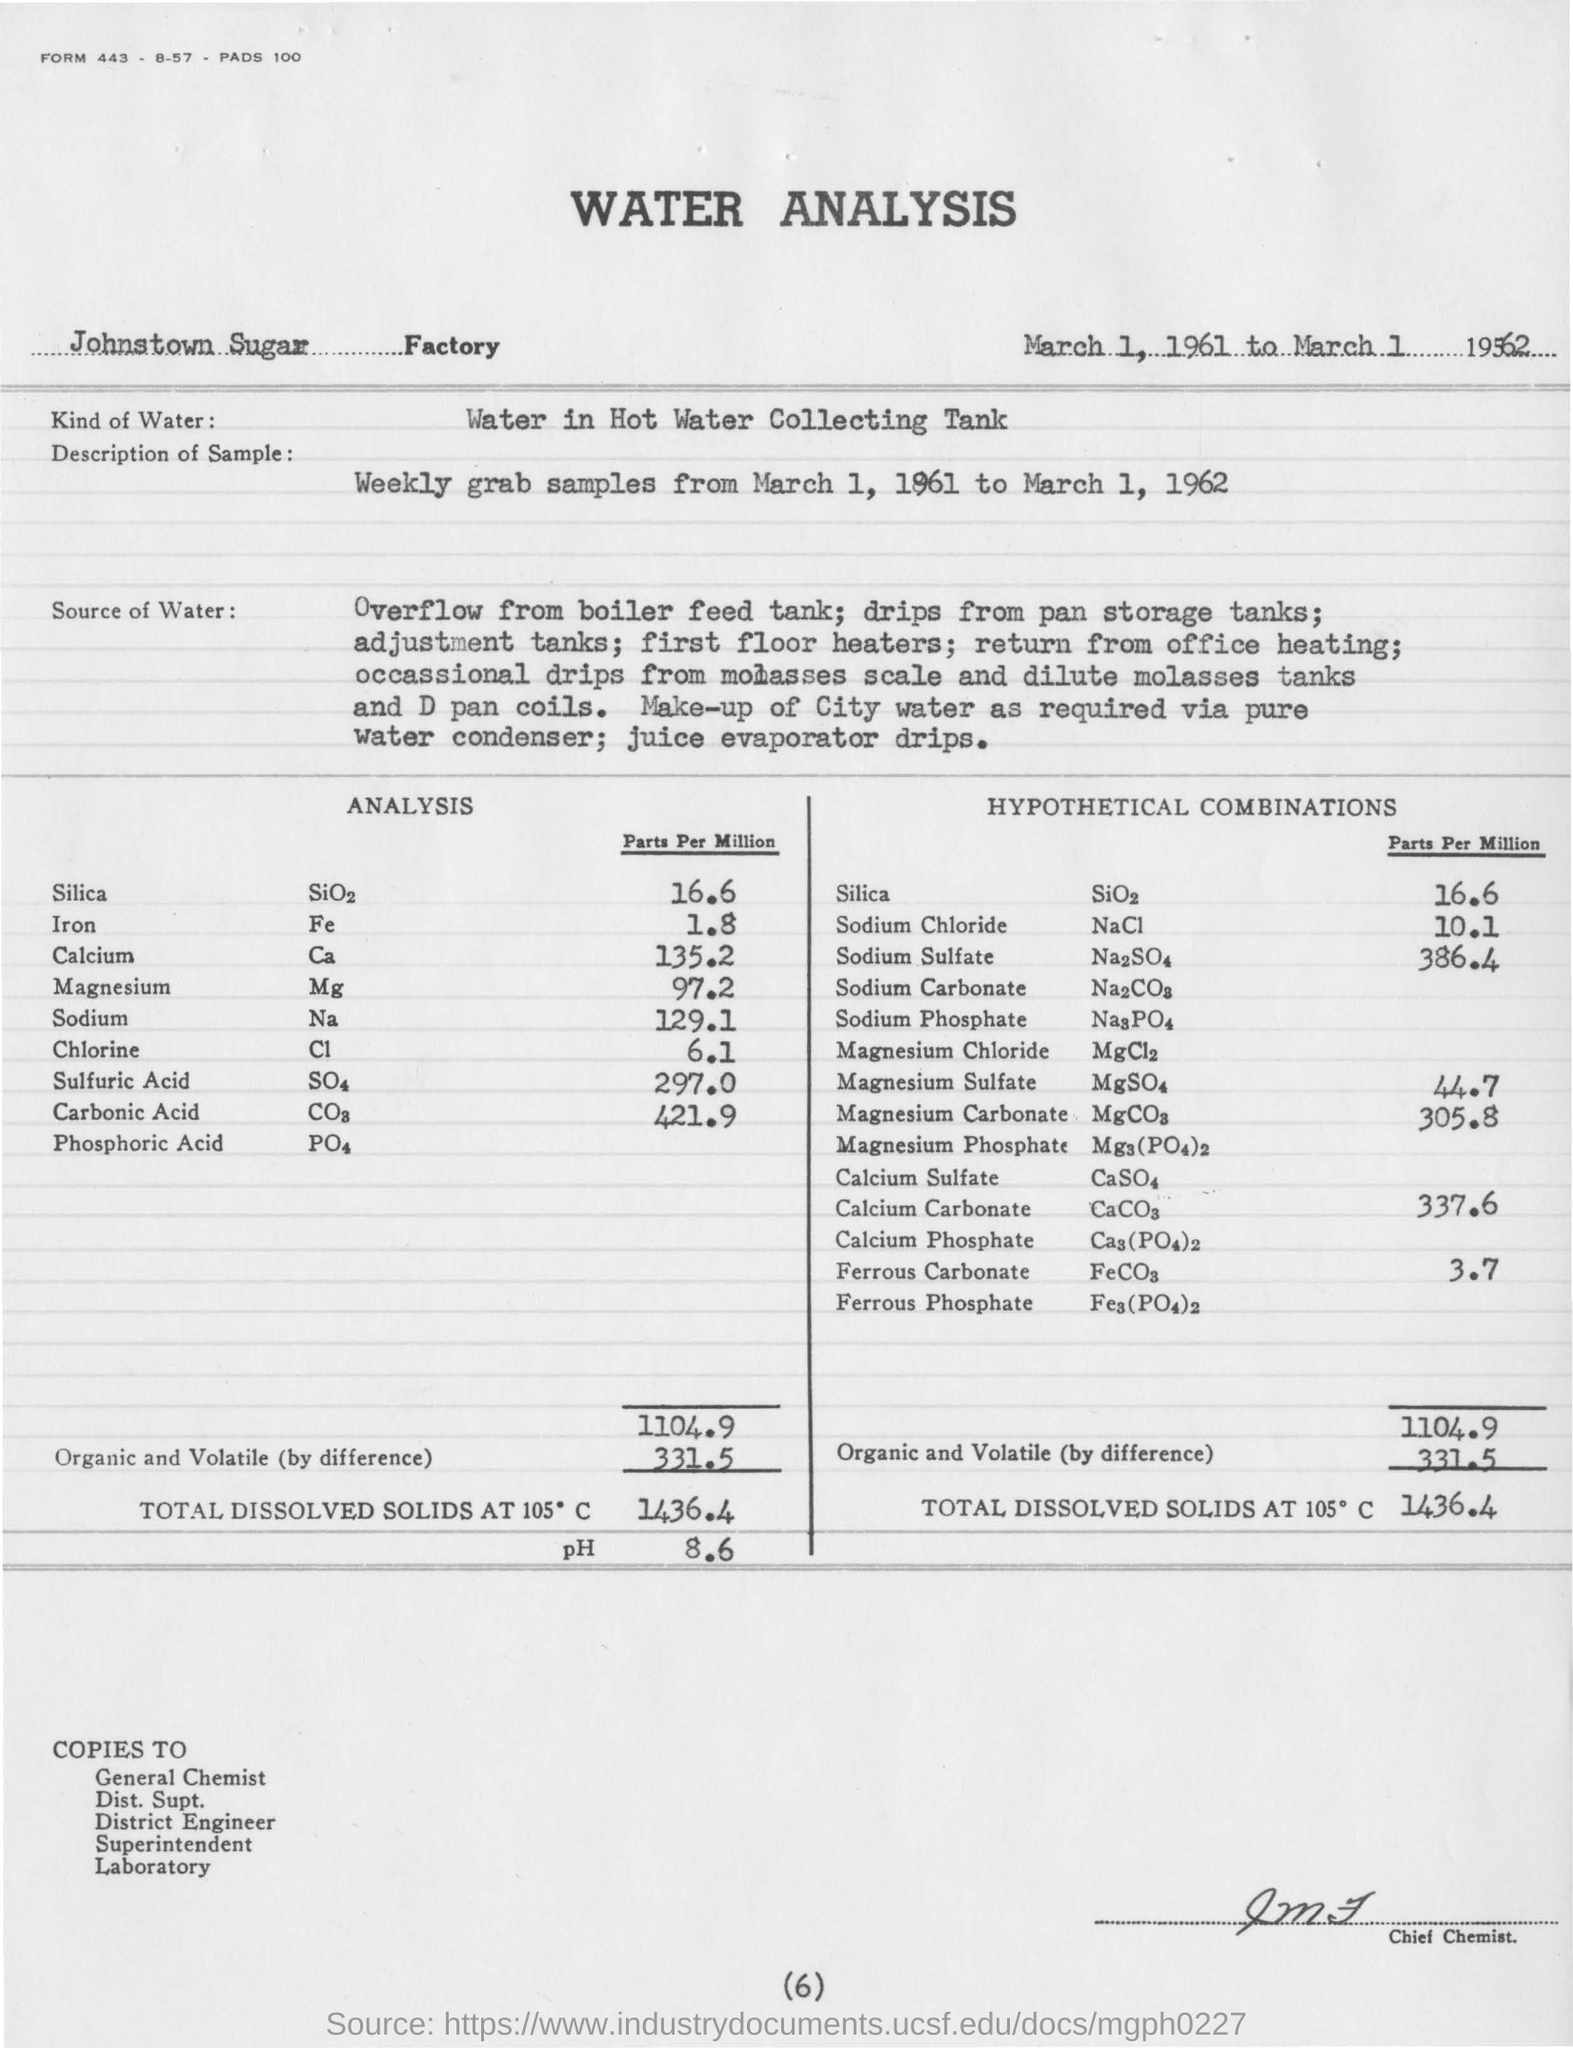Which kind of water is mentioned in the analysis report?
Your answer should be very brief. Water in Hot Water Collecting Tank. How much pH value is mentioned in the report
Your response must be concise. 8.6. 